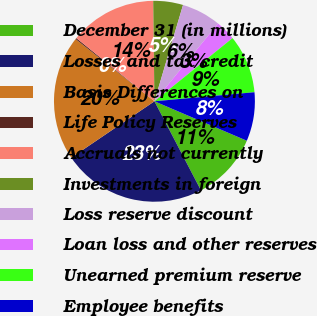Convert chart to OTSL. <chart><loc_0><loc_0><loc_500><loc_500><pie_chart><fcel>December 31 (in millions)<fcel>Losses and tax credit<fcel>Basis Differences on<fcel>Life Policy Reserves<fcel>Accruals not currently<fcel>Investments in foreign<fcel>Loss reserve discount<fcel>Loan loss and other reserves<fcel>Unearned premium reserve<fcel>Employee benefits<nl><fcel>10.92%<fcel>23.17%<fcel>20.11%<fcel>0.2%<fcel>13.98%<fcel>4.79%<fcel>6.32%<fcel>3.26%<fcel>9.39%<fcel>7.86%<nl></chart> 